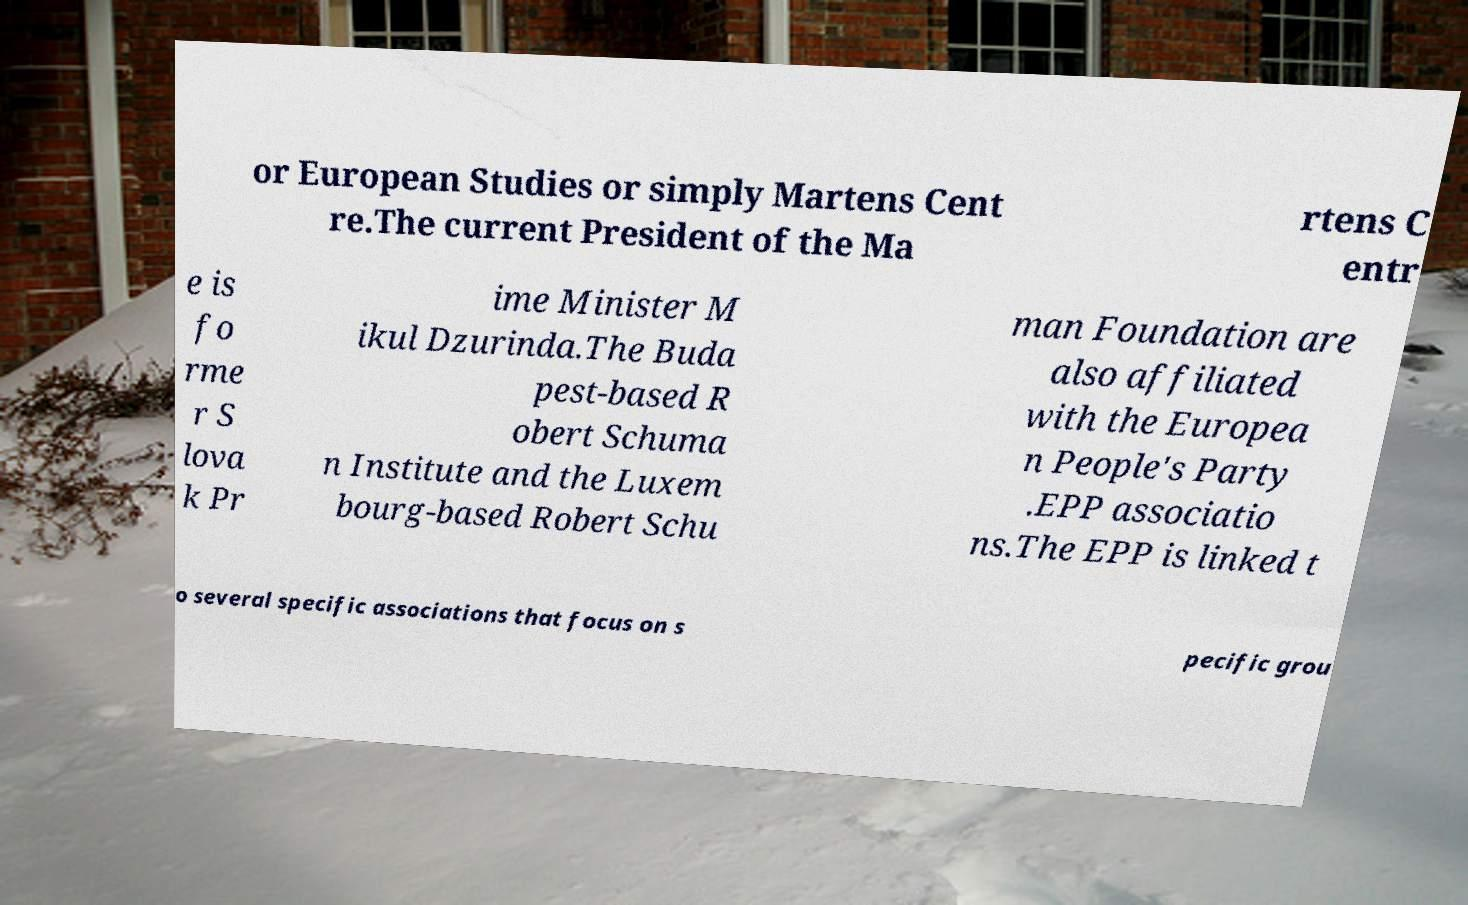Can you accurately transcribe the text from the provided image for me? or European Studies or simply Martens Cent re.The current President of the Ma rtens C entr e is fo rme r S lova k Pr ime Minister M ikul Dzurinda.The Buda pest-based R obert Schuma n Institute and the Luxem bourg-based Robert Schu man Foundation are also affiliated with the Europea n People's Party .EPP associatio ns.The EPP is linked t o several specific associations that focus on s pecific grou 